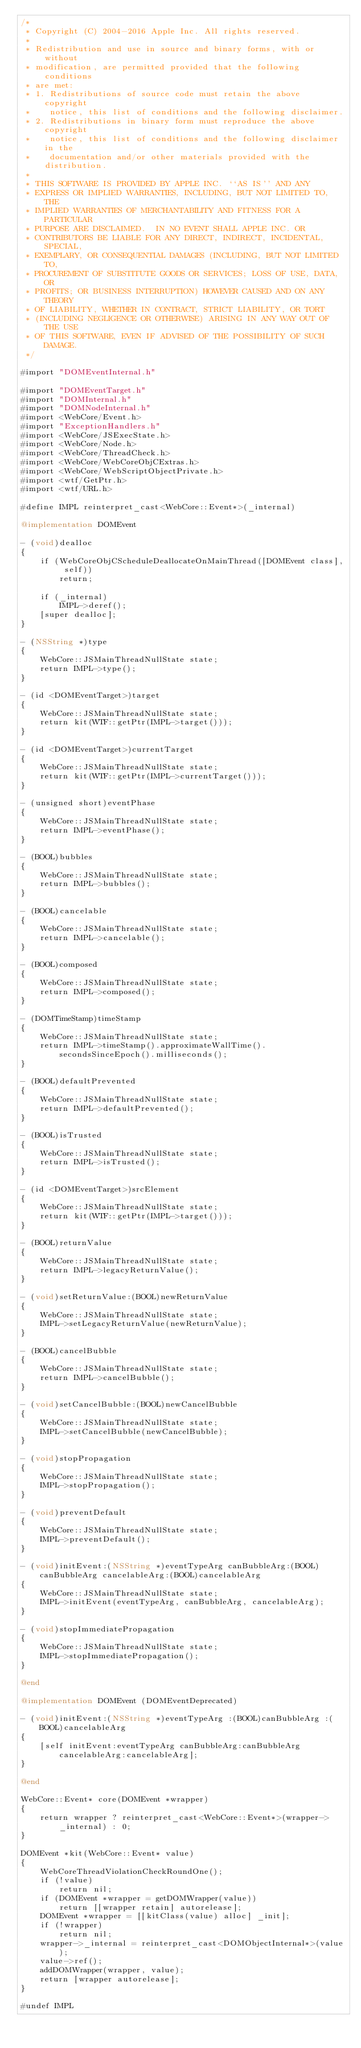<code> <loc_0><loc_0><loc_500><loc_500><_ObjectiveC_>/*
 * Copyright (C) 2004-2016 Apple Inc. All rights reserved.
 *
 * Redistribution and use in source and binary forms, with or without
 * modification, are permitted provided that the following conditions
 * are met:
 * 1. Redistributions of source code must retain the above copyright
 *    notice, this list of conditions and the following disclaimer.
 * 2. Redistributions in binary form must reproduce the above copyright
 *    notice, this list of conditions and the following disclaimer in the
 *    documentation and/or other materials provided with the distribution.
 *
 * THIS SOFTWARE IS PROVIDED BY APPLE INC. ``AS IS'' AND ANY
 * EXPRESS OR IMPLIED WARRANTIES, INCLUDING, BUT NOT LIMITED TO, THE
 * IMPLIED WARRANTIES OF MERCHANTABILITY AND FITNESS FOR A PARTICULAR
 * PURPOSE ARE DISCLAIMED.  IN NO EVENT SHALL APPLE INC. OR
 * CONTRIBUTORS BE LIABLE FOR ANY DIRECT, INDIRECT, INCIDENTAL, SPECIAL,
 * EXEMPLARY, OR CONSEQUENTIAL DAMAGES (INCLUDING, BUT NOT LIMITED TO,
 * PROCUREMENT OF SUBSTITUTE GOODS OR SERVICES; LOSS OF USE, DATA, OR
 * PROFITS; OR BUSINESS INTERRUPTION) HOWEVER CAUSED AND ON ANY THEORY
 * OF LIABILITY, WHETHER IN CONTRACT, STRICT LIABILITY, OR TORT
 * (INCLUDING NEGLIGENCE OR OTHERWISE) ARISING IN ANY WAY OUT OF THE USE
 * OF THIS SOFTWARE, EVEN IF ADVISED OF THE POSSIBILITY OF SUCH DAMAGE.
 */

#import "DOMEventInternal.h"

#import "DOMEventTarget.h"
#import "DOMInternal.h"
#import "DOMNodeInternal.h"
#import <WebCore/Event.h>
#import "ExceptionHandlers.h"
#import <WebCore/JSExecState.h>
#import <WebCore/Node.h>
#import <WebCore/ThreadCheck.h>
#import <WebCore/WebCoreObjCExtras.h>
#import <WebCore/WebScriptObjectPrivate.h>
#import <wtf/GetPtr.h>
#import <wtf/URL.h>

#define IMPL reinterpret_cast<WebCore::Event*>(_internal)

@implementation DOMEvent

- (void)dealloc
{
    if (WebCoreObjCScheduleDeallocateOnMainThread([DOMEvent class], self))
        return;

    if (_internal)
        IMPL->deref();
    [super dealloc];
}

- (NSString *)type
{
    WebCore::JSMainThreadNullState state;
    return IMPL->type();
}

- (id <DOMEventTarget>)target
{
    WebCore::JSMainThreadNullState state;
    return kit(WTF::getPtr(IMPL->target()));
}

- (id <DOMEventTarget>)currentTarget
{
    WebCore::JSMainThreadNullState state;
    return kit(WTF::getPtr(IMPL->currentTarget()));
}

- (unsigned short)eventPhase
{
    WebCore::JSMainThreadNullState state;
    return IMPL->eventPhase();
}

- (BOOL)bubbles
{
    WebCore::JSMainThreadNullState state;
    return IMPL->bubbles();
}

- (BOOL)cancelable
{
    WebCore::JSMainThreadNullState state;
    return IMPL->cancelable();
}

- (BOOL)composed
{
    WebCore::JSMainThreadNullState state;
    return IMPL->composed();
}

- (DOMTimeStamp)timeStamp
{
    WebCore::JSMainThreadNullState state;
    return IMPL->timeStamp().approximateWallTime().secondsSinceEpoch().milliseconds();
}

- (BOOL)defaultPrevented
{
    WebCore::JSMainThreadNullState state;
    return IMPL->defaultPrevented();
}

- (BOOL)isTrusted
{
    WebCore::JSMainThreadNullState state;
    return IMPL->isTrusted();
}

- (id <DOMEventTarget>)srcElement
{
    WebCore::JSMainThreadNullState state;
    return kit(WTF::getPtr(IMPL->target()));
}

- (BOOL)returnValue
{
    WebCore::JSMainThreadNullState state;
    return IMPL->legacyReturnValue();
}

- (void)setReturnValue:(BOOL)newReturnValue
{
    WebCore::JSMainThreadNullState state;
    IMPL->setLegacyReturnValue(newReturnValue);
}

- (BOOL)cancelBubble
{
    WebCore::JSMainThreadNullState state;
    return IMPL->cancelBubble();
}

- (void)setCancelBubble:(BOOL)newCancelBubble
{
    WebCore::JSMainThreadNullState state;
    IMPL->setCancelBubble(newCancelBubble);
}

- (void)stopPropagation
{
    WebCore::JSMainThreadNullState state;
    IMPL->stopPropagation();
}

- (void)preventDefault
{
    WebCore::JSMainThreadNullState state;
    IMPL->preventDefault();
}

- (void)initEvent:(NSString *)eventTypeArg canBubbleArg:(BOOL)canBubbleArg cancelableArg:(BOOL)cancelableArg
{
    WebCore::JSMainThreadNullState state;
    IMPL->initEvent(eventTypeArg, canBubbleArg, cancelableArg);
}

- (void)stopImmediatePropagation
{
    WebCore::JSMainThreadNullState state;
    IMPL->stopImmediatePropagation();
}

@end

@implementation DOMEvent (DOMEventDeprecated)

- (void)initEvent:(NSString *)eventTypeArg :(BOOL)canBubbleArg :(BOOL)cancelableArg
{
    [self initEvent:eventTypeArg canBubbleArg:canBubbleArg cancelableArg:cancelableArg];
}

@end

WebCore::Event* core(DOMEvent *wrapper)
{
    return wrapper ? reinterpret_cast<WebCore::Event*>(wrapper->_internal) : 0;
}

DOMEvent *kit(WebCore::Event* value)
{
    WebCoreThreadViolationCheckRoundOne();
    if (!value)
        return nil;
    if (DOMEvent *wrapper = getDOMWrapper(value))
        return [[wrapper retain] autorelease];
    DOMEvent *wrapper = [[kitClass(value) alloc] _init];
    if (!wrapper)
        return nil;
    wrapper->_internal = reinterpret_cast<DOMObjectInternal*>(value);
    value->ref();
    addDOMWrapper(wrapper, value);
    return [wrapper autorelease];
}

#undef IMPL
</code> 